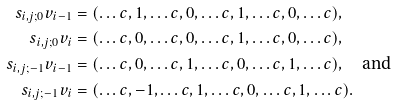Convert formula to latex. <formula><loc_0><loc_0><loc_500><loc_500>s _ { i , j ; 0 } v _ { i - 1 } & = ( \dots c , 1 , \dots c , 0 , \dots c , 1 , \dots c , 0 , \dots c ) , \\ s _ { i , j ; 0 } v _ { i } & = ( \dots c , 0 , \dots c , 0 , \dots c , 1 , \dots c , 0 , \dots c ) , \\ s _ { i , j ; - 1 } v _ { i - 1 } & = ( \dots c , 0 , \dots c , 1 , \dots c , 0 , \dots c , 1 , \dots c ) , \quad \text {and} \\ s _ { i , j ; - 1 } v _ { i } & = ( \dots c , - 1 , \dots c , 1 , \dots c , 0 , \dots c , 1 , \dots c ) .</formula> 